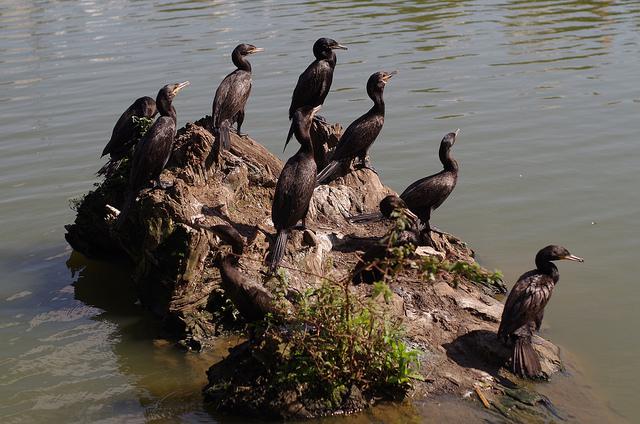What are the birds standing on?
Be succinct. Rock. Is this bird getting ready to fly?
Quick response, please. No. What kind of birds are these?
Give a very brief answer. Ducks. Are the ducklings walking on the grass or swimming in water?
Be succinct. No. How many birds?
Quick response, please. 8. How many ducks are there?
Answer briefly. 9. How many ducks are here?
Be succinct. 8. 